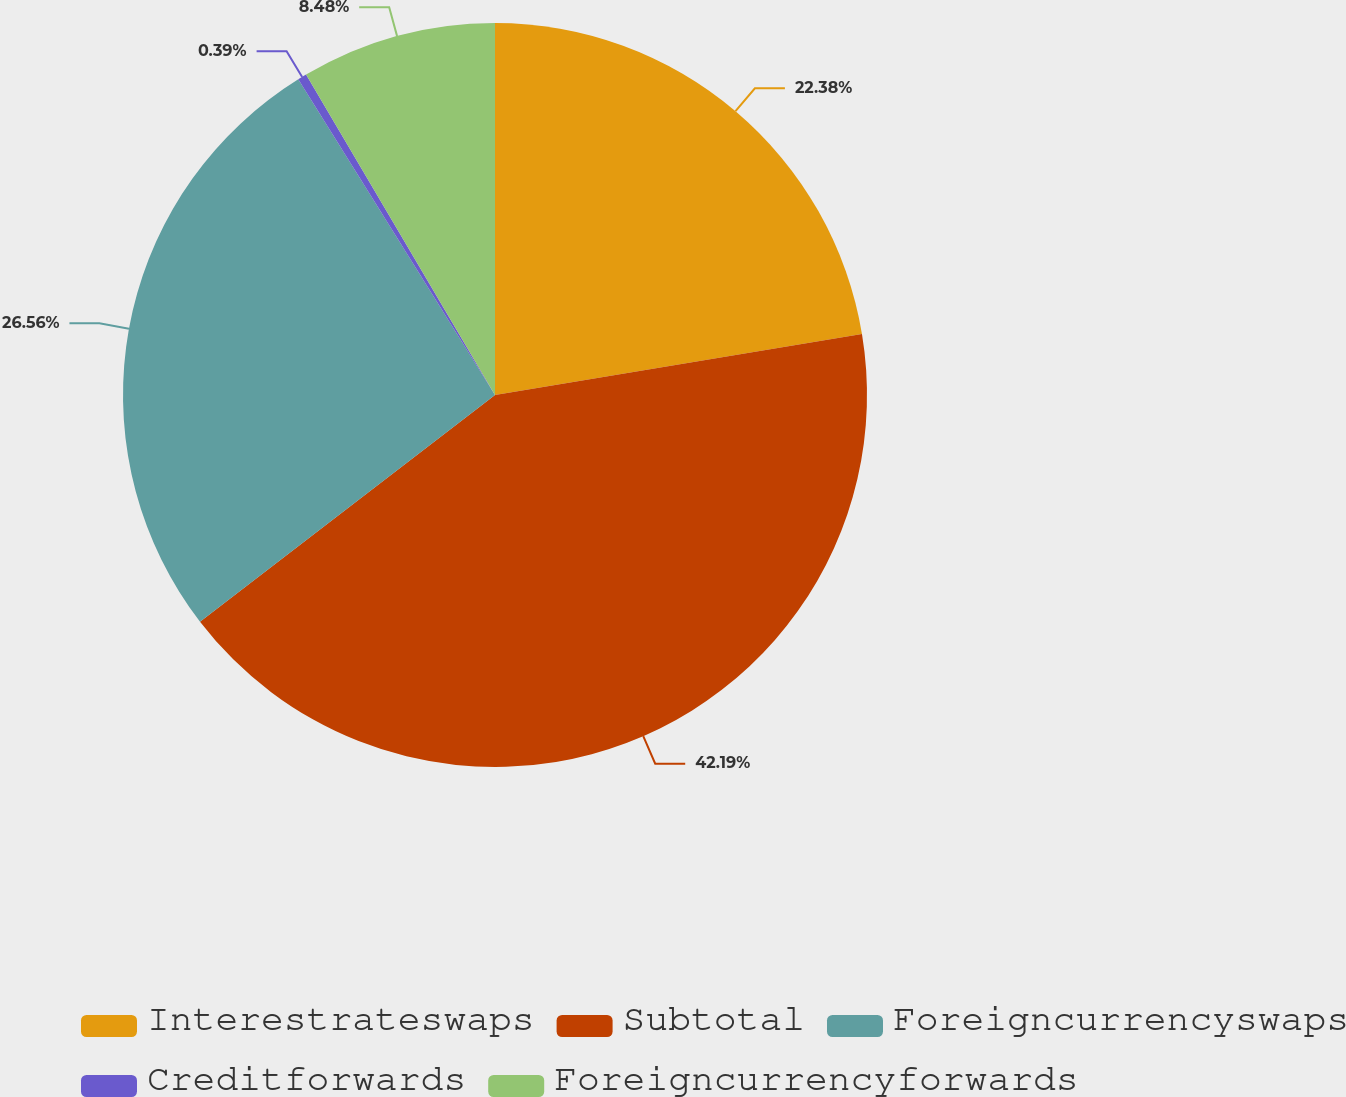Convert chart to OTSL. <chart><loc_0><loc_0><loc_500><loc_500><pie_chart><fcel>Interestrateswaps<fcel>Subtotal<fcel>Foreigncurrencyswaps<fcel>Creditforwards<fcel>Foreigncurrencyforwards<nl><fcel>22.38%<fcel>42.2%<fcel>26.56%<fcel>0.39%<fcel>8.48%<nl></chart> 